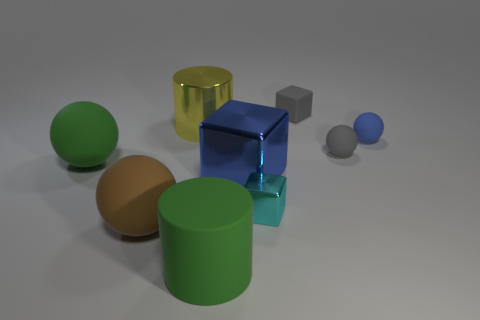There is a blue thing that is to the right of the tiny matte cube; how big is it?
Offer a very short reply. Small. What size is the gray ball that is the same material as the small gray block?
Ensure brevity in your answer.  Small. What number of small matte things have the same color as the matte cube?
Make the answer very short. 1. Are there any big blue shiny blocks?
Keep it short and to the point. Yes. Does the cyan object have the same shape as the gray object that is behind the blue ball?
Make the answer very short. Yes. What is the color of the big shiny thing that is behind the big green thing to the left of the green object right of the yellow object?
Ensure brevity in your answer.  Yellow. There is a large green sphere; are there any shiny objects in front of it?
Keep it short and to the point. Yes. What is the size of the thing that is the same color as the big rubber cylinder?
Your answer should be compact. Large. Is there a large blue cube that has the same material as the brown object?
Give a very brief answer. No. The big shiny cylinder is what color?
Ensure brevity in your answer.  Yellow. 